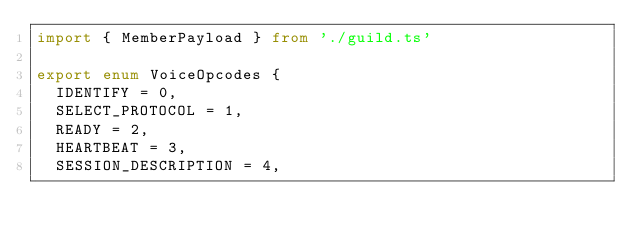Convert code to text. <code><loc_0><loc_0><loc_500><loc_500><_TypeScript_>import { MemberPayload } from './guild.ts'

export enum VoiceOpcodes {
  IDENTIFY = 0,
  SELECT_PROTOCOL = 1,
  READY = 2,
  HEARTBEAT = 3,
  SESSION_DESCRIPTION = 4,</code> 